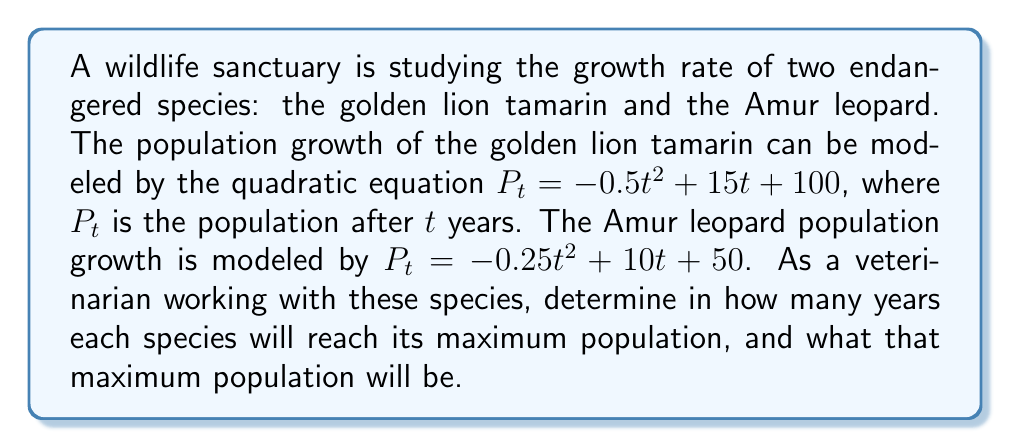Could you help me with this problem? To solve this problem, we need to find the vertex of each quadratic equation, as the vertex represents the maximum point of the parabola.

For a quadratic equation in the form $f(x) = ax^2 + bx + c$, the x-coordinate of the vertex is given by $x = -\frac{b}{2a}$, and the y-coordinate can be found by substituting this x-value back into the original equation.

1. For the golden lion tamarin:
   $P_t = -0.5t^2 + 15t + 100$
   $a = -0.5$, $b = 15$, $c = 100$

   Time to reach maximum population: $t = -\frac{b}{2a} = -\frac{15}{2(-0.5)} = 15$ years

   Maximum population: 
   $P_{max} = -0.5(15)^2 + 15(15) + 100$
   $= -0.5(225) + 225 + 100$
   $= -112.5 + 225 + 100$
   $= 212.5$

2. For the Amur leopard:
   $P_t = -0.25t^2 + 10t + 50$
   $a = -0.25$, $b = 10$, $c = 50$

   Time to reach maximum population: $t = -\frac{b}{2a} = -\frac{10}{2(-0.25)} = 20$ years

   Maximum population:
   $P_{max} = -0.25(20)^2 + 10(20) + 50$
   $= -0.25(400) + 200 + 50$
   $= -100 + 200 + 50$
   $= 150$
Answer: The golden lion tamarin will reach its maximum population of 213 individuals (rounded up from 212.5) after 15 years. The Amur leopard will reach its maximum population of 150 individuals after 20 years. 